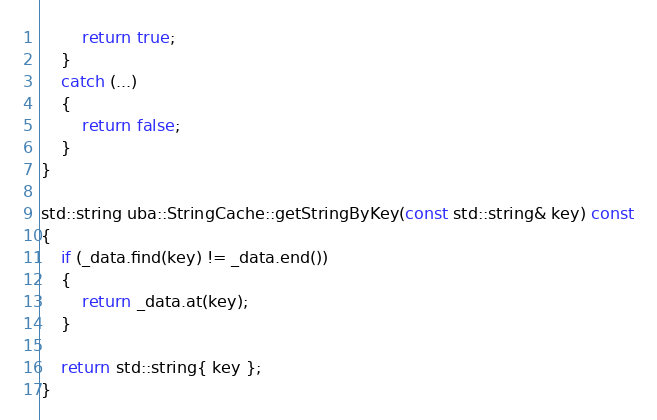<code> <loc_0><loc_0><loc_500><loc_500><_C++_>		return true;
	}
	catch (...)
	{
		return false;
	}
}

std::string uba::StringCache::getStringByKey(const std::string& key) const
{
	if (_data.find(key) != _data.end())
	{
		return _data.at(key);
	}
	
	return std::string{ key };
}
</code> 